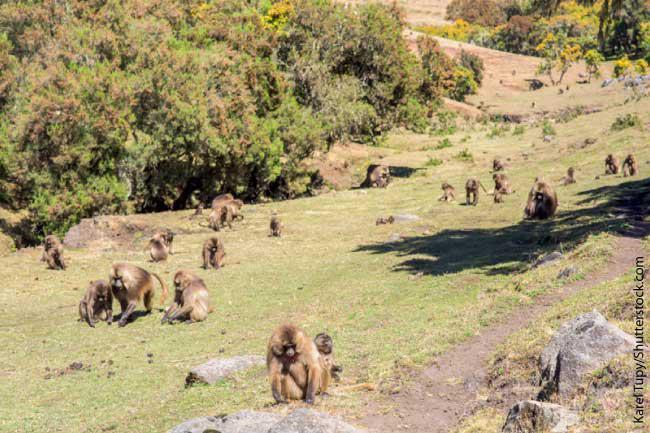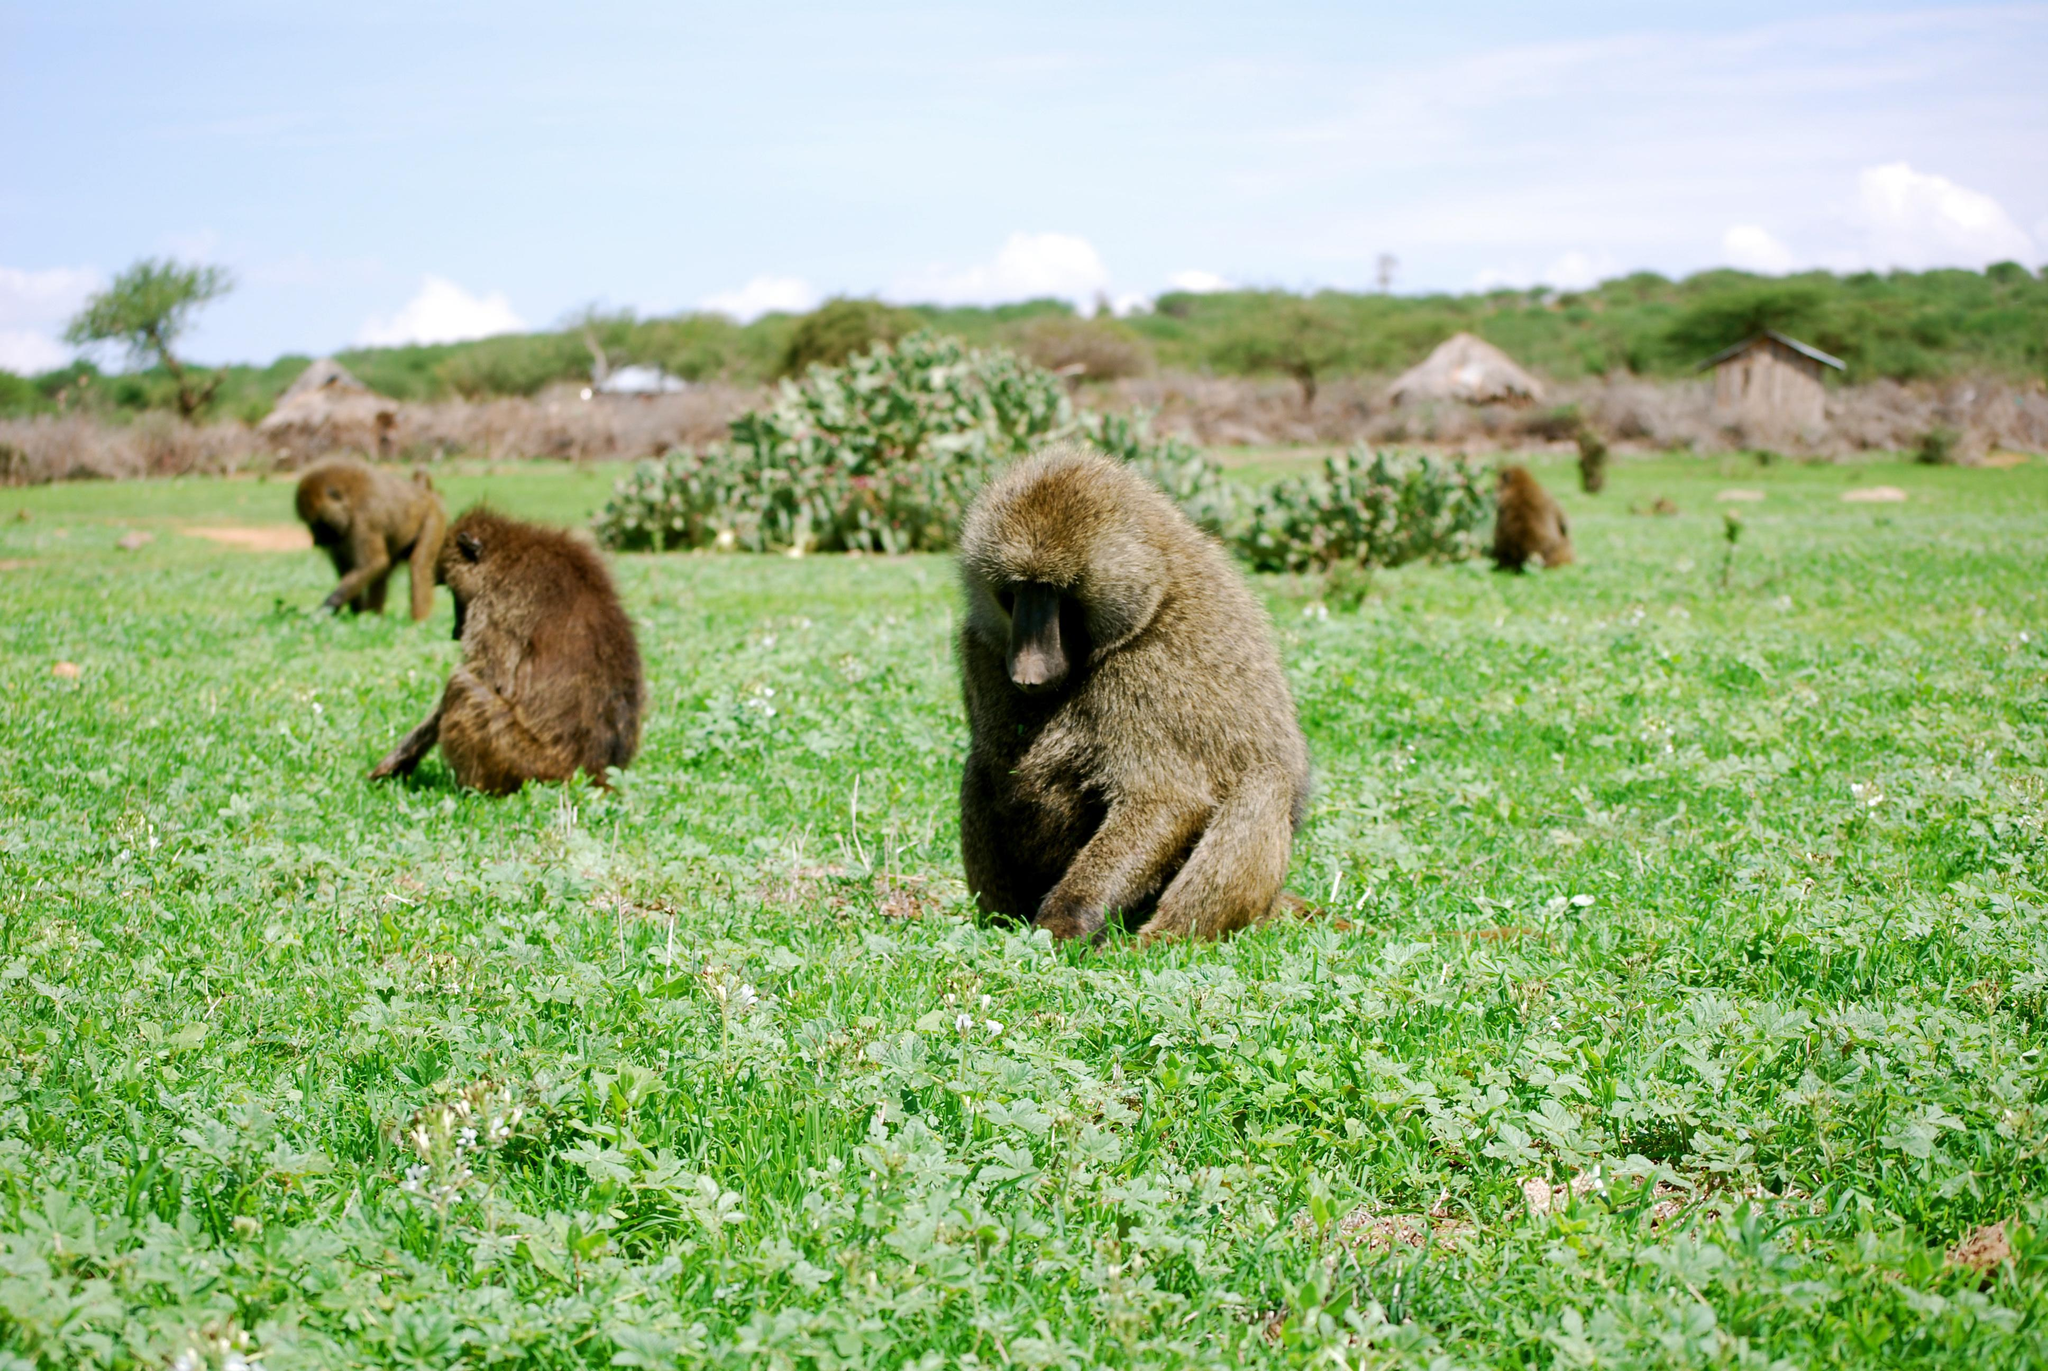The first image is the image on the left, the second image is the image on the right. For the images shown, is this caption "Some of the animals are on or near a dirt path." true? Answer yes or no. Yes. The first image is the image on the left, the second image is the image on the right. Analyze the images presented: Is the assertion "Right image includes no more than five baboons." valid? Answer yes or no. Yes. 